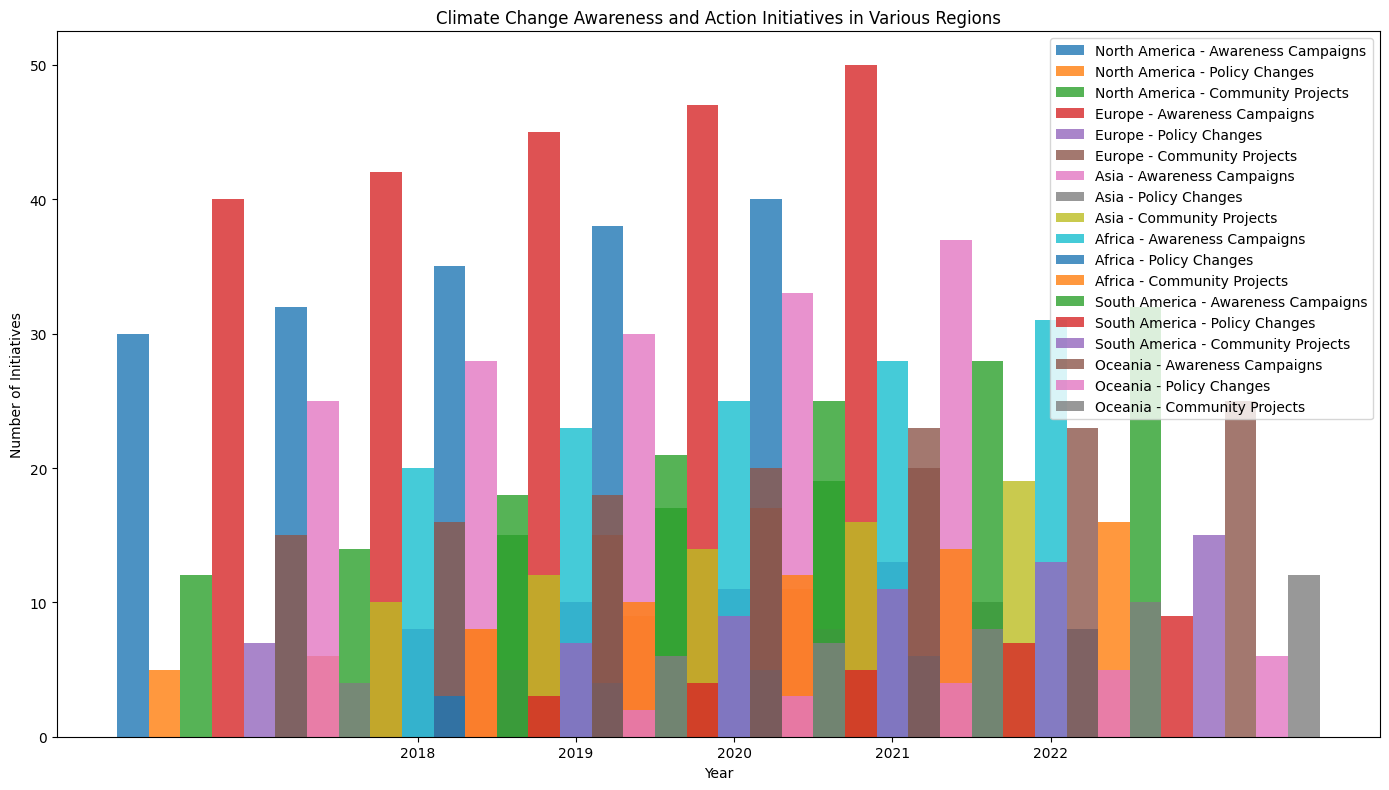Which region had the highest number of Awareness Campaigns in 2022? To find this, look at the bars representing Awareness Campaigns in 2022 across all regions. Identify the tallest bar. In 2022, Europe has the highest number for Awareness Campaigns.
Answer: Europe Which initiative type showed the most significant growth in North America from 2018 to 2022? Calculate the difference between the 2018 and 2022 values for each initiative type in North America. Awareness Campaigns increased by 10 (40-30), Policy Changes by 6 (11-5), and Community Projects by 7 (19-12). The most significant growth is in Awareness Campaigns.
Answer: Awareness Campaigns Between 2018 and 2022, which region had the lowest increase in Policy Changes? Calculate the increase in the number of Policy Changes from 2018 to 2022 for each region. For North America: 11-5=6, Europe: 13-7=6, Asia: 10-4=6, Africa: 8-3=5, South America: 9-3=6, Oceania: 6-2=4. Oceania has the lowest increase.
Answer: Oceania What was the total number of Community Projects across all regions in 2021? Sum the values of Community Projects in 2021 for each region: North America: 17, Europe: 20, Asia: 16, Africa: 14, South America: 13, Oceania: 10. The total is 17+20+16+14+13+10=90.
Answer: 90 Did the number of Awareness Campaigns in Asia surpass that in North America at any point between 2018 and 2022? Compare the values of Awareness Campaigns in Asia and North America for each year. In all years 2018-2022, North America's numbers (30, 32, 35, 38, 40) were consistently higher than Asia's (25, 28, 30, 33, 37). Therefore, Asia never surpassed North America.
Answer: No Which region had an equal number of Community Projects and Policy Changes in any year? Examine if any region has equal values for Community Projects and Policy Changes in any single year. Upon review, no region in 2018, 2019, 2020, 2021, or 2022 had equal values for these initiatives.
Answer: None How did the number of Policy Changes initiative in Africa change from 2019 to 2020 compared to Oceania? From the plot, note the values for Policy Changes in Africa (2019: 4, 2020: 5) and Oceania (2019: 3, 2020: 4). Both regions show an increase of 1 in the number of Policy Changes initiatives from 2019 to 2020.
Answer: Both increased by 1 